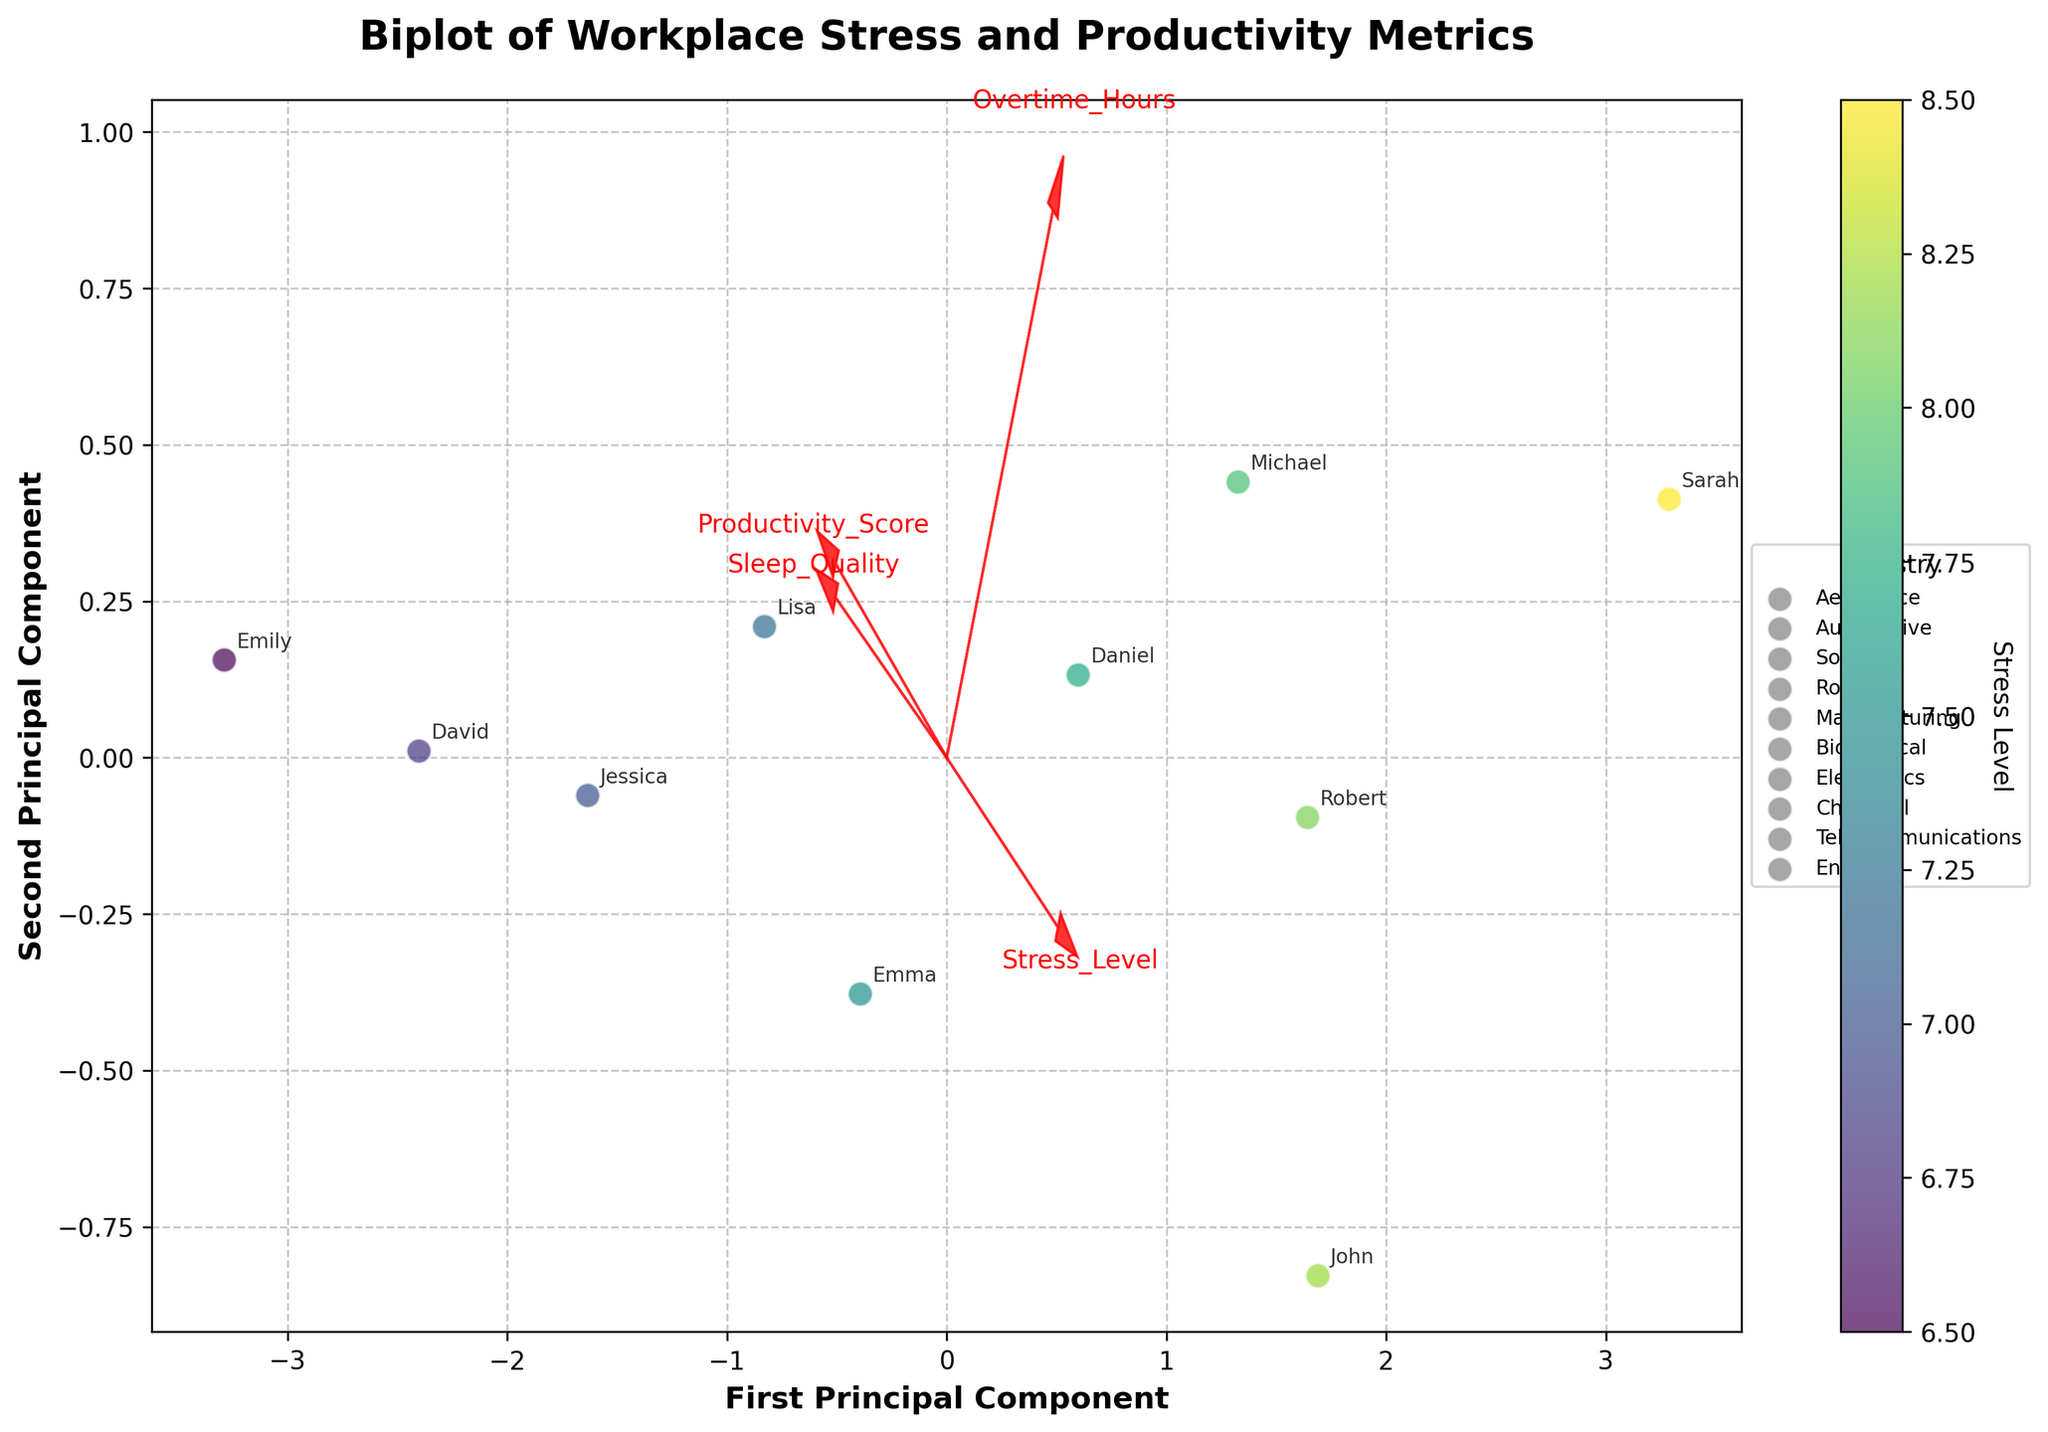What is the title of the plot? The title of the plot is usually found at the top and provides a brief summary of the visualized data. Here, the title states "Biplot of Workplace Stress and Productivity Metrics".
Answer: Biplot of Workplace Stress and Productivity Metrics How many industries are represented in the plot? By looking at the legend on the right side of the plot, various unique industries are listed. These include Aerospace, Automotive, Software, Robotics, Manufacturing, Biomedical, Electronics, Chemical, Telecommunications, and Energy. Counting them gives the total number of industries.
Answer: 10 Which feature vector has the largest arrow in the biplot? To determine the longest feature vector, we look at the arrows originating from (0, 0) and measure their lengths in the plot. The "Overtime_Hours" vector appears to be the longest.
Answer: Overtime_Hours Which engineer appears to have the lowest Sleep Quality in the plot? By inspecting the locations of engineers with labels and the arrows, Sarah appears closer to the negative direction of the "Sleep_Quality" vector, suggesting lower sleep quality.
Answer: Sarah Can we see a group of engineers from the same industry clustering together? By observing the scatter plot and the labels, we see that engineers from different industries are mostly scattered, without significant clustering of individuals from the same industry.
Answer: No Which engineer has the highest Productivity Score in the biplot? The colorbar indicates stress levels, but productivity could be inferred by the distance along principal components. Emily from the Chemical industry has high productivity based on her position relative to the Productivity_Score vector.
Answer: Emily How do the features "Stress_Level" and "Overtime_Hours" relate to the first principal component (PC1)? By examining the direction and magnitude of the arrows along the PC1 axis, both "Stress_Level" and "Overtime_Hours" show significant positive contributions, suggesting they influence PC1 strongly.
Answer: Positive contribution Which industry has the highest average Stress_Level as represented in the figure? Since the plot is colored by Stress_Level and includes annotations, identifying the highest averaged colors (considering the scatter hues and labels) gives Aerospace (John) and Robotics (Sarah) which both represent industries with high stress levels.
Answer: Aerospace or Robotics Is there an apparent trade-off between Sleep Quality and Productivity Score based on the biplot? Observing the vectors for Sleep_Quality and Productivity_Score, they point in different directions, indicating an inverse relationship. This suggests a trade-off where higher productivity might relate to lower sleep quality.
Answer: Yes Which combinations of features contribute most to the second principal component (PC2)? By inspecting the arrows along PC2, the vectors for "Sleep_Quality" and "Productivity_Score" show higher alignment with the PC2 axis. This means they contribute most to PC2.
Answer: Sleep_Quality and Productivity_Score 